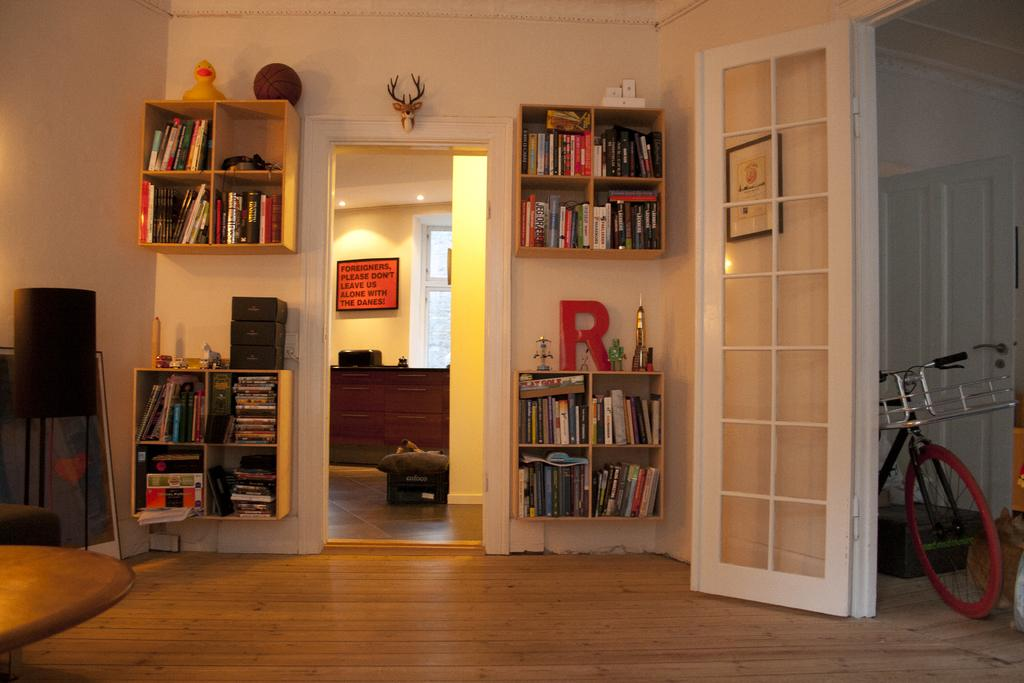Provide a one-sentence caption for the provided image. a bookcase in a house with the letter R above it. 